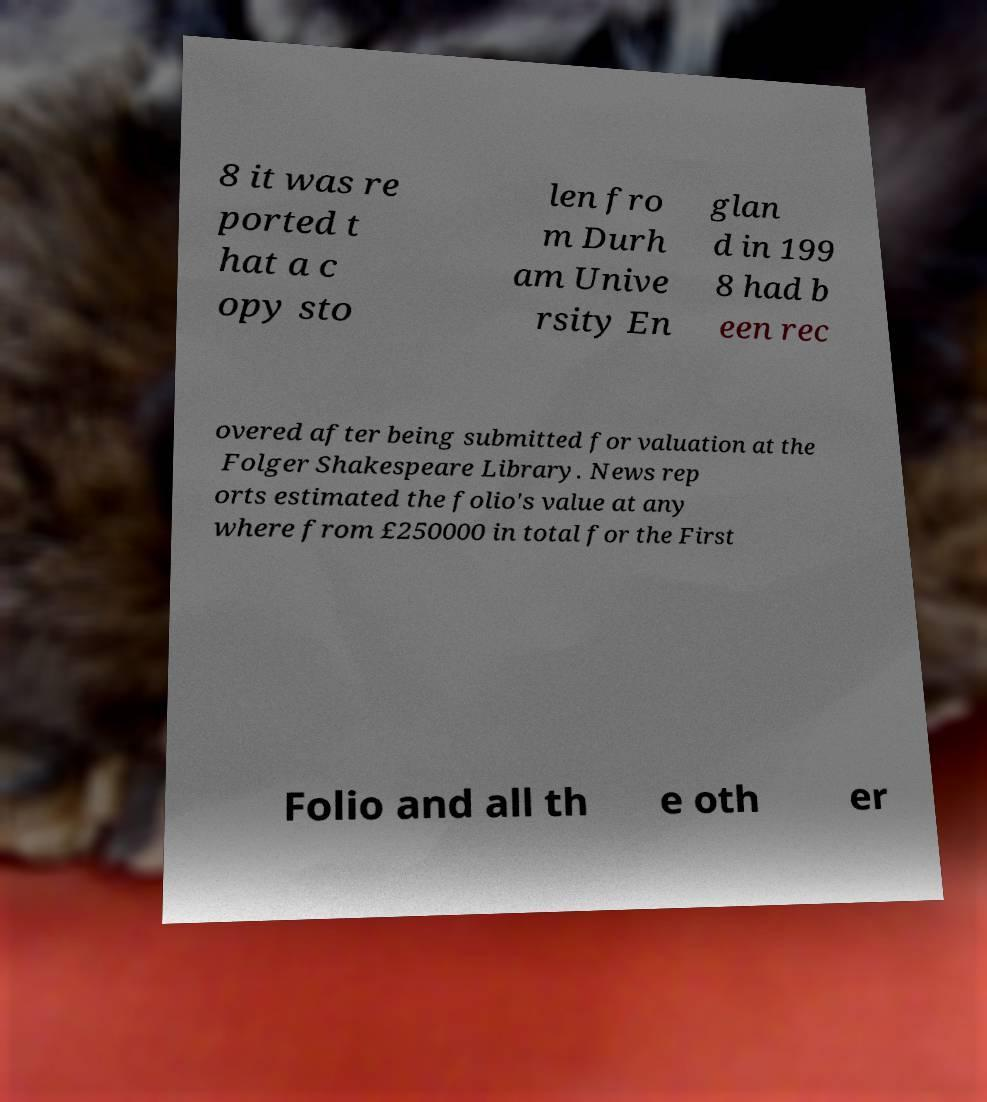Can you read and provide the text displayed in the image?This photo seems to have some interesting text. Can you extract and type it out for me? 8 it was re ported t hat a c opy sto len fro m Durh am Unive rsity En glan d in 199 8 had b een rec overed after being submitted for valuation at the Folger Shakespeare Library. News rep orts estimated the folio's value at any where from £250000 in total for the First Folio and all th e oth er 